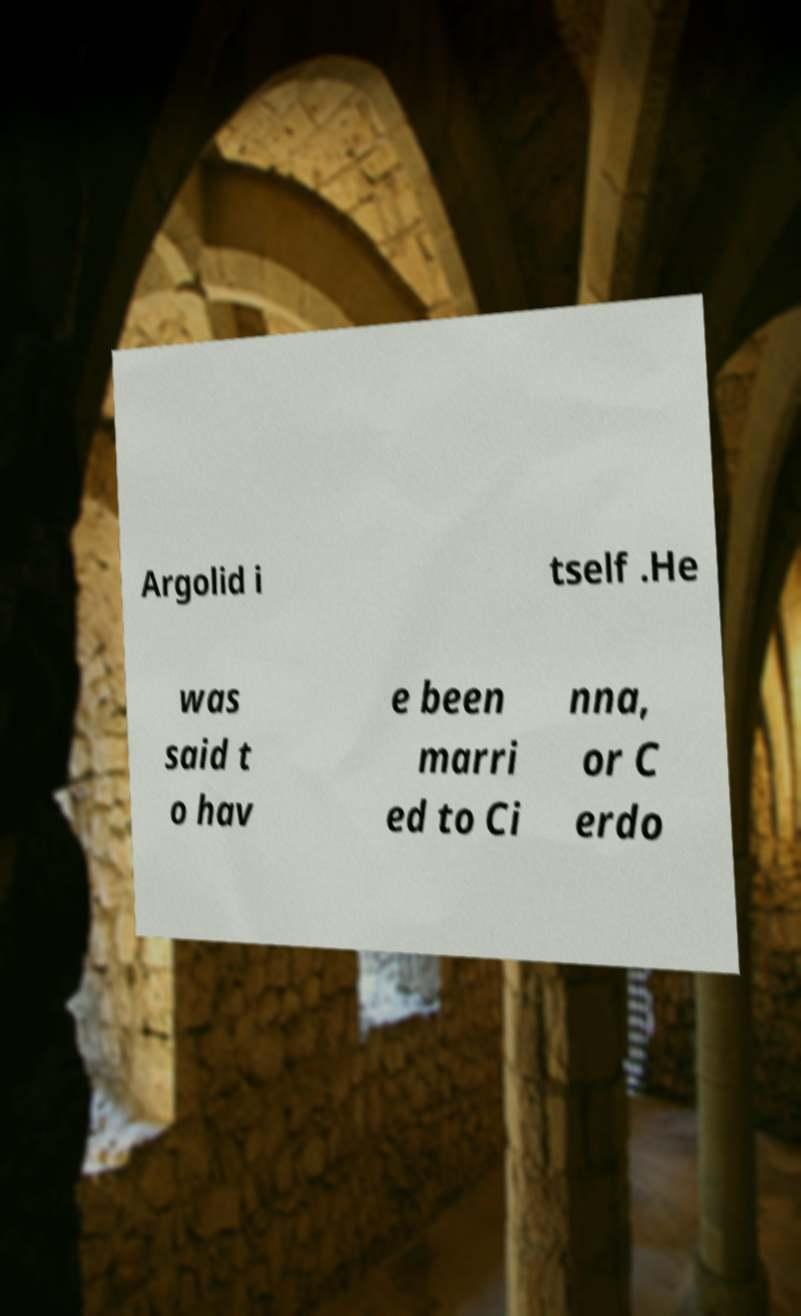Could you extract and type out the text from this image? Argolid i tself .He was said t o hav e been marri ed to Ci nna, or C erdo 